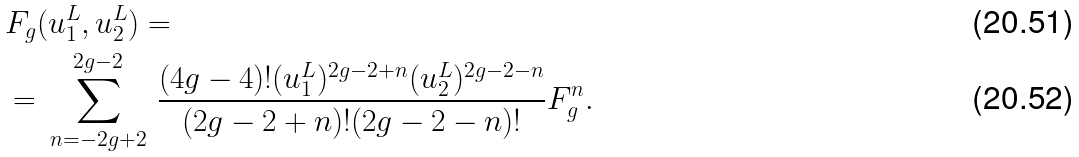Convert formula to latex. <formula><loc_0><loc_0><loc_500><loc_500>& F _ { g } ( u ^ { L } _ { 1 } , u ^ { L } _ { 2 } ) = \\ & = \, \sum _ { n = - 2 g + 2 } ^ { 2 g - 2 } \, \frac { ( 4 g - 4 ) ! ( u _ { 1 } ^ { L } ) ^ { 2 g - 2 + n } ( u _ { 2 } ^ { L } ) ^ { 2 g - 2 - n } } { ( 2 g - 2 + n ) ! ( 2 g - 2 - n ) ! } F _ { g } ^ { n } .</formula> 